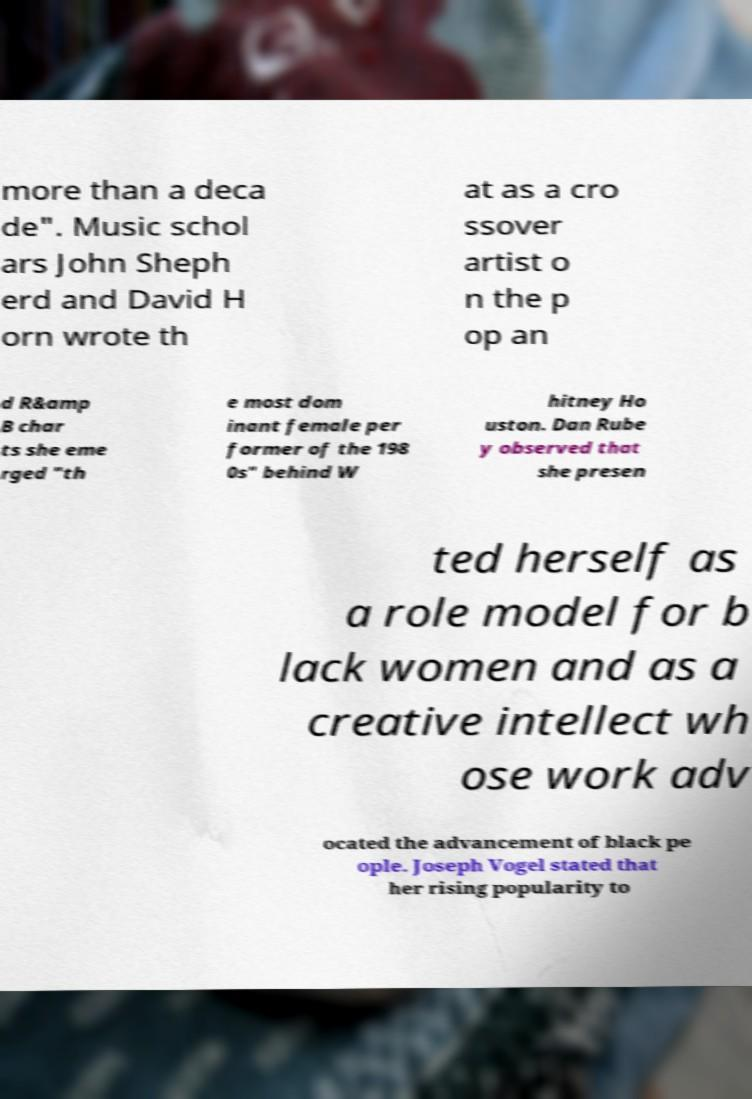Can you accurately transcribe the text from the provided image for me? more than a deca de". Music schol ars John Sheph erd and David H orn wrote th at as a cro ssover artist o n the p op an d R&amp B char ts she eme rged "th e most dom inant female per former of the 198 0s" behind W hitney Ho uston. Dan Rube y observed that she presen ted herself as a role model for b lack women and as a creative intellect wh ose work adv ocated the advancement of black pe ople. Joseph Vogel stated that her rising popularity to 